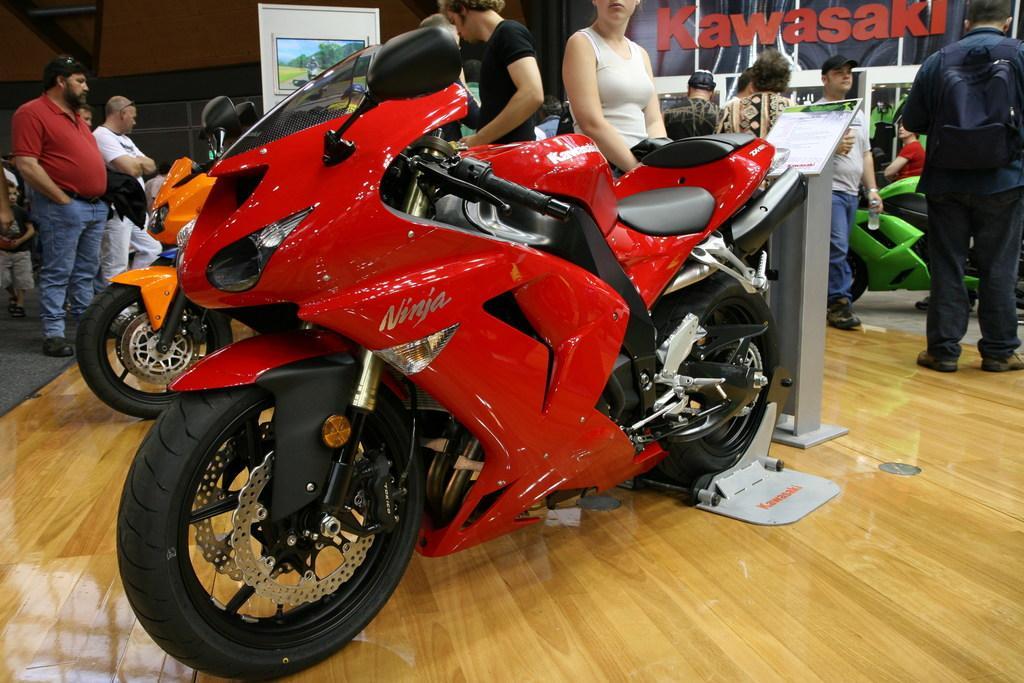Can you describe this image briefly? In this image we can see bikes on the floor. In the background, we can see people, wall and boards. 